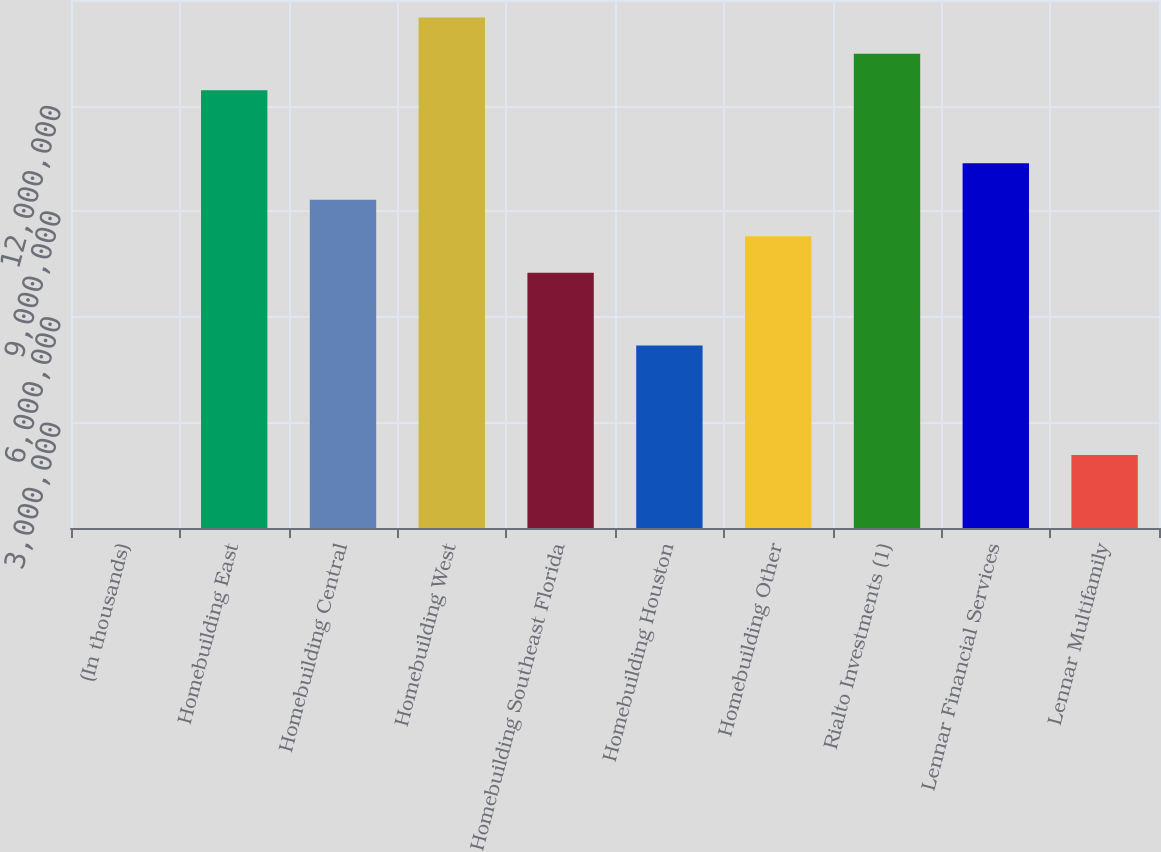<chart> <loc_0><loc_0><loc_500><loc_500><bar_chart><fcel>(In thousands)<fcel>Homebuilding East<fcel>Homebuilding Central<fcel>Homebuilding West<fcel>Homebuilding Southeast Florida<fcel>Homebuilding Houston<fcel>Homebuilding Other<fcel>Rialto Investments (1)<fcel>Lennar Financial Services<fcel>Lennar Multifamily<nl><fcel>2012<fcel>1.24342e+07<fcel>9.32619e+06<fcel>1.45063e+07<fcel>7.25415e+06<fcel>5.18211e+06<fcel>8.29017e+06<fcel>1.34703e+07<fcel>1.03622e+07<fcel>2.07405e+06<nl></chart> 